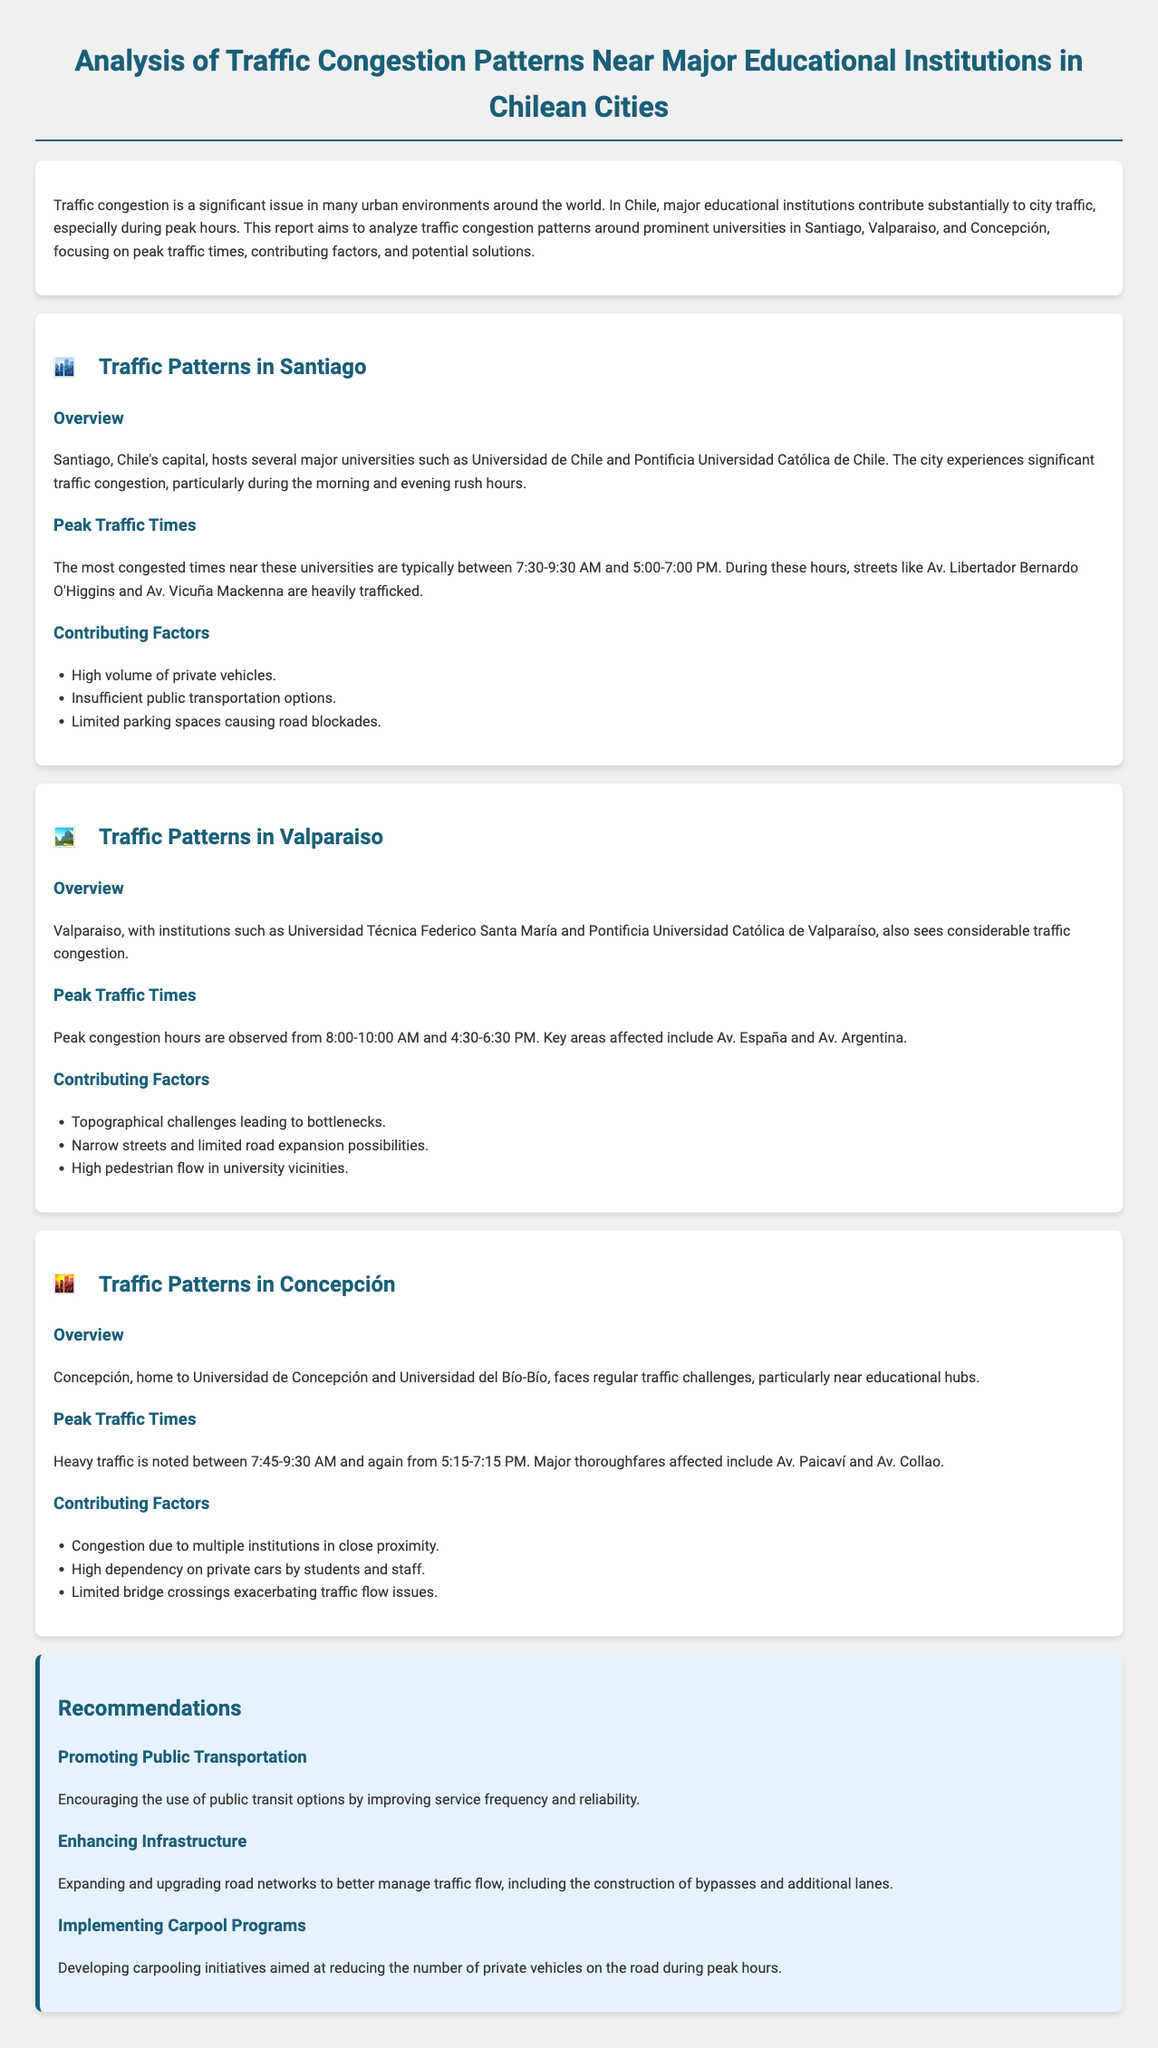What are the peak traffic times in Santiago? The report states that the most congested times near the universities in Santiago are typically between 7:30-9:30 AM and 5:00-7:00 PM.
Answer: 7:30-9:30 AM and 5:00-7:00 PM What major universities are located in Valparaiso? The document mentions Universidad Técnica Federico Santa María and Pontificia Universidad Católica de Valparaíso as major institutions in Valparaiso.
Answer: Universidad Técnica Federico Santa María and Pontificia Universidad Católica de Valparaíso What are the contributing factors to traffic congestion in Concepción? The report lists several factors, including congestion due to multiple institutions in close proximity and high dependency on private cars.
Answer: Congestion due to multiple institutions What is a recommended solution to traffic congestion? The document suggests promoting public transportation as a solution to traffic congestion around educational institutions.
Answer: Promoting public transportation What are the peak traffic times in Valparaiso? The peak congestion hours in Valparaiso are stated as from 8:00-10:00 AM and 4:30-6:30 PM.
Answer: 8:00-10:00 AM and 4:30-6:30 PM 